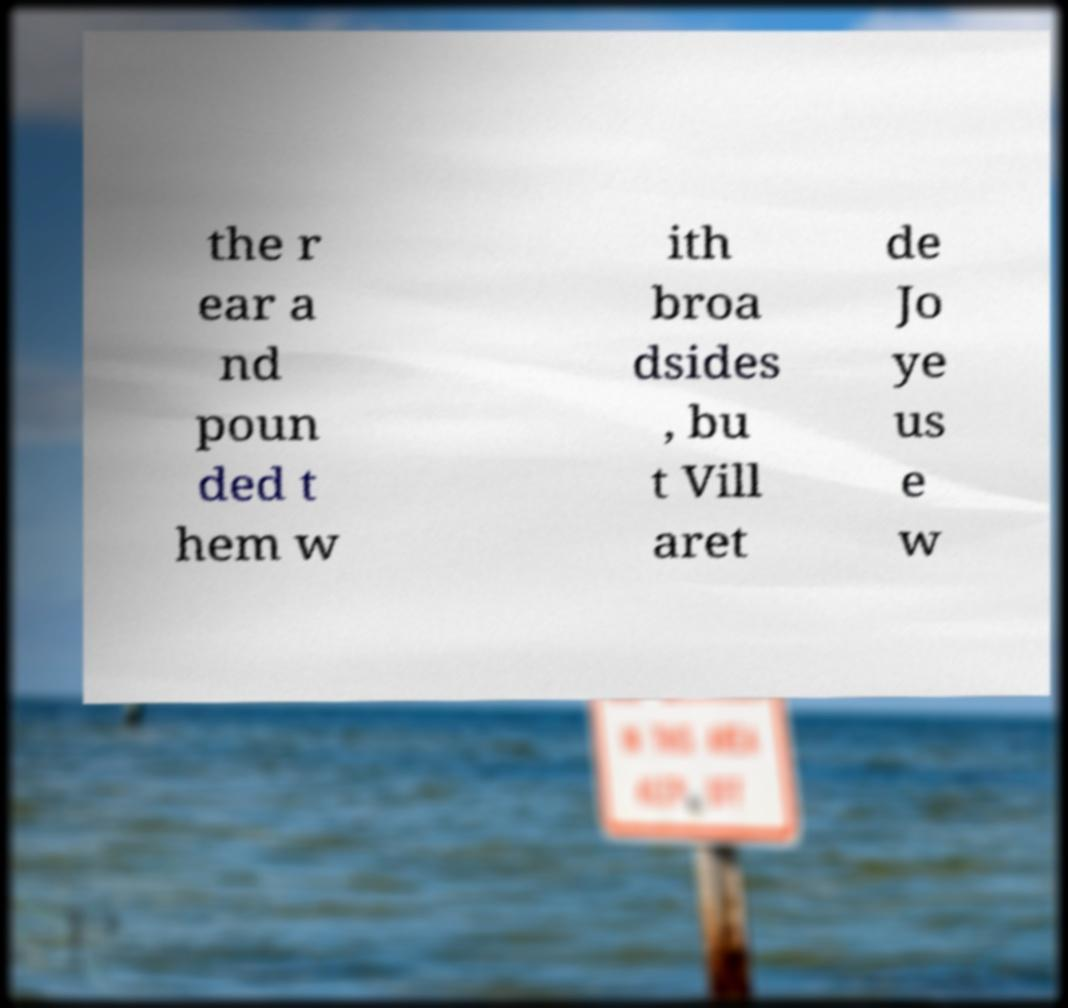For documentation purposes, I need the text within this image transcribed. Could you provide that? the r ear a nd poun ded t hem w ith broa dsides , bu t Vill aret de Jo ye us e w 